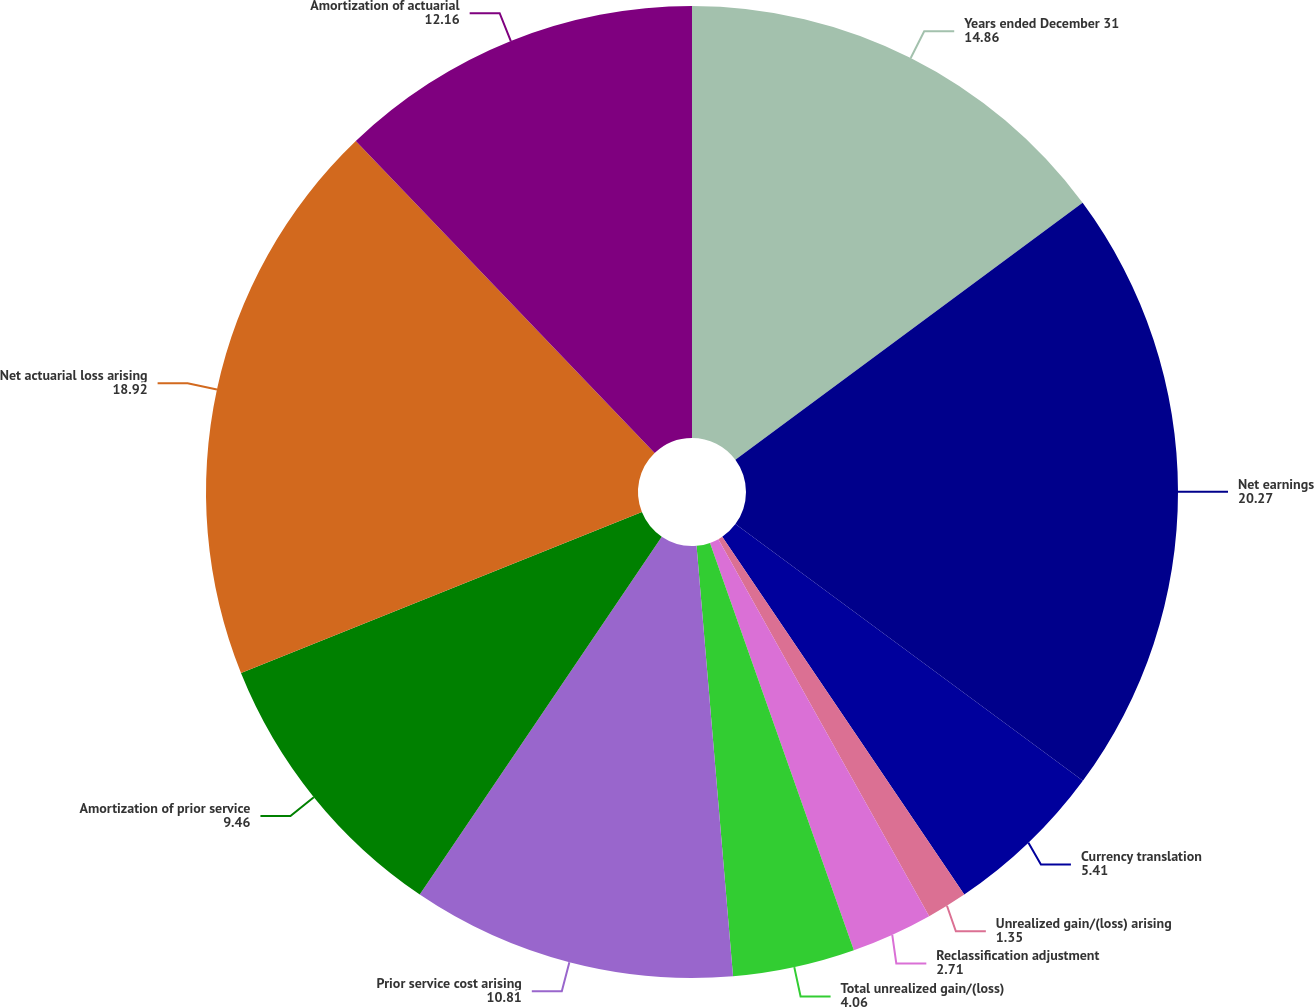Convert chart to OTSL. <chart><loc_0><loc_0><loc_500><loc_500><pie_chart><fcel>Years ended December 31<fcel>Net earnings<fcel>Currency translation<fcel>Unrealized gain/(loss) arising<fcel>Reclassification adjustment<fcel>Total unrealized gain/(loss)<fcel>Prior service cost arising<fcel>Amortization of prior service<fcel>Net actuarial loss arising<fcel>Amortization of actuarial<nl><fcel>14.86%<fcel>20.27%<fcel>5.41%<fcel>1.35%<fcel>2.71%<fcel>4.06%<fcel>10.81%<fcel>9.46%<fcel>18.92%<fcel>12.16%<nl></chart> 